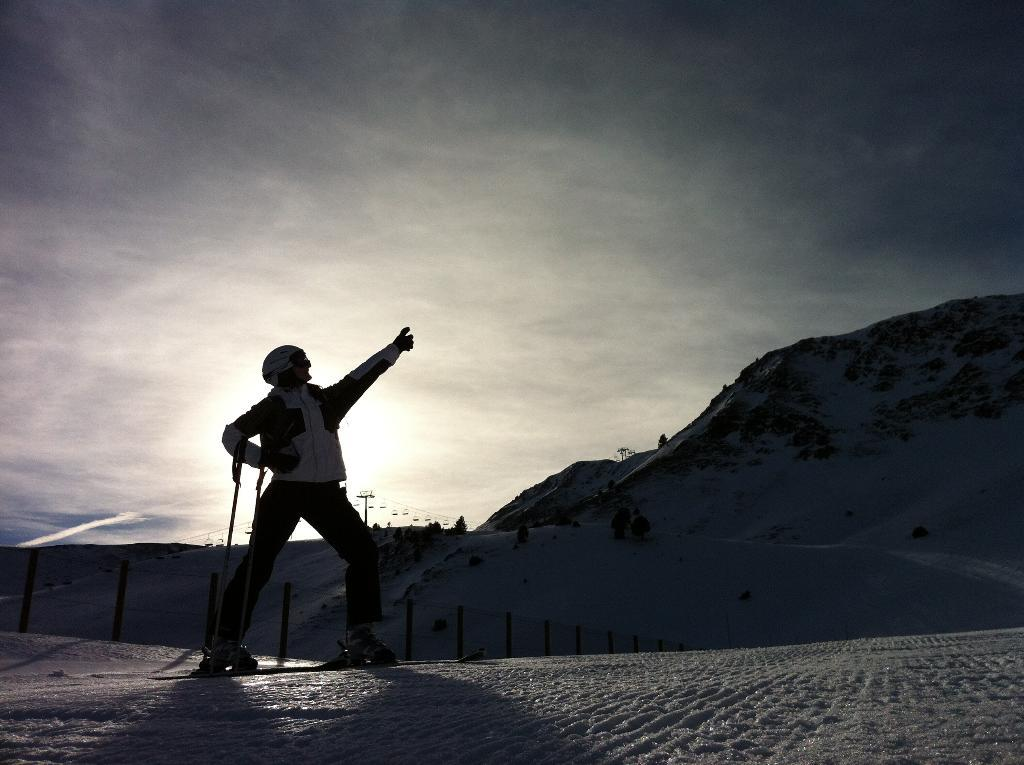What is the main subject of the image? There is a person standing in the image. What is the person doing in the image? The person is raising his hand. What is the environment like in the image? There is snow everywhere in the image. Can you see any snakes slithering through the snow in the image? No, there are no snakes present in the image. How many fish are swimming in the snow in the image? There are no fish present in the image, as it is covered in snow. 